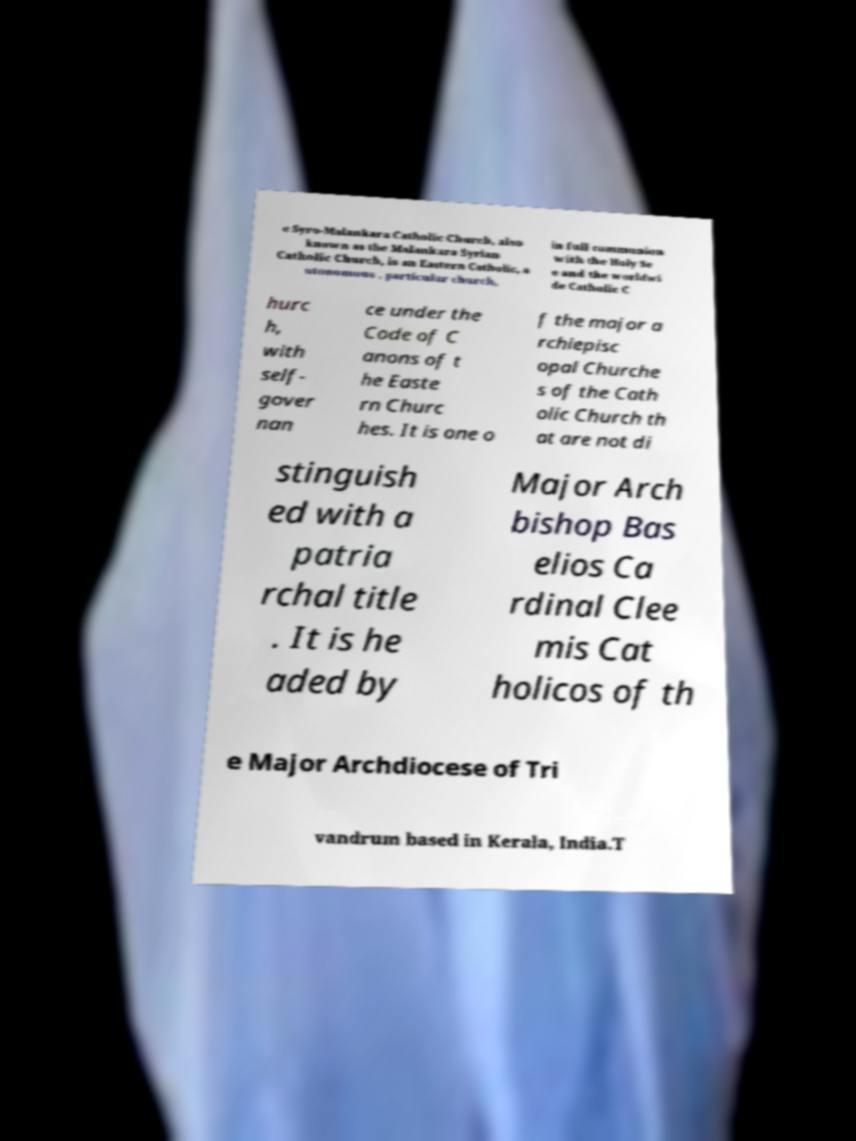Could you assist in decoding the text presented in this image and type it out clearly? e Syro-Malankara Catholic Church, also known as the Malankara Syrian Catholic Church, is an Eastern Catholic, a utonomous , particular church, in full communion with the Holy Se e and the worldwi de Catholic C hurc h, with self- gover nan ce under the Code of C anons of t he Easte rn Churc hes. It is one o f the major a rchiepisc opal Churche s of the Cath olic Church th at are not di stinguish ed with a patria rchal title . It is he aded by Major Arch bishop Bas elios Ca rdinal Clee mis Cat holicos of th e Major Archdiocese of Tri vandrum based in Kerala, India.T 